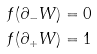<formula> <loc_0><loc_0><loc_500><loc_500>f ( \partial _ { - } W ) & = { 0 } \\ f ( \partial _ { + } W ) & = { 1 }</formula> 